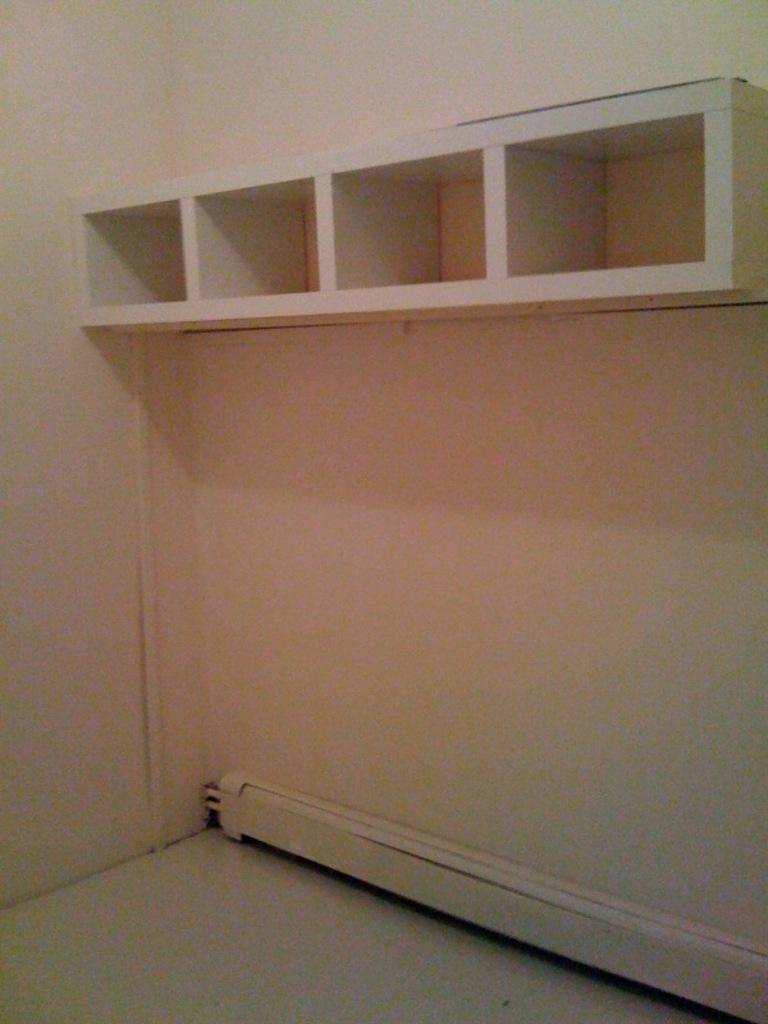What type of structure can be seen in the image? There are shelves in the image. What is the background of the image? There is a wall in the image. How many pens are on the shelves in the image? There is no information about pens in the image, as it only mentions the presence of shelves and a wall. 